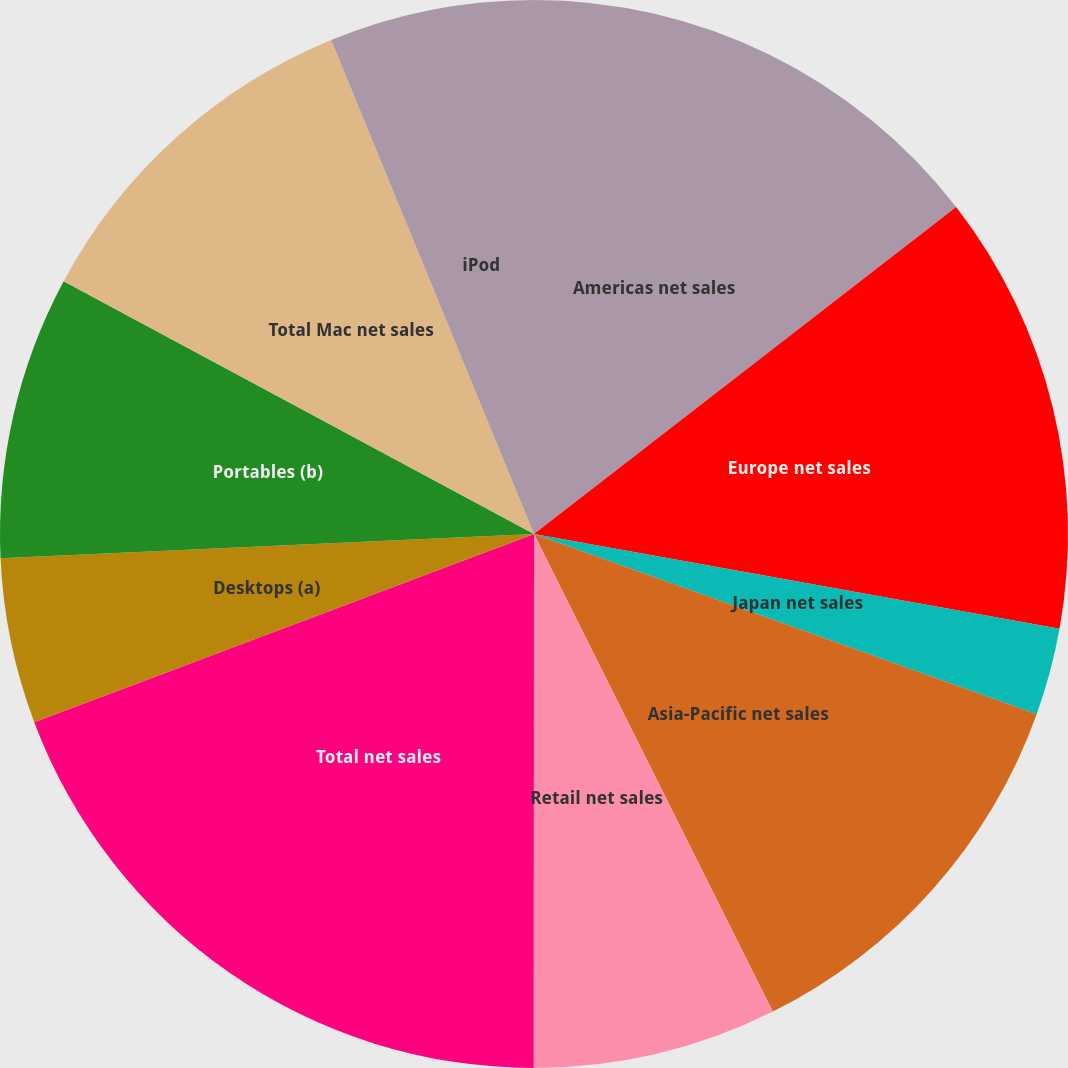Convert chart. <chart><loc_0><loc_0><loc_500><loc_500><pie_chart><fcel>Americas net sales<fcel>Europe net sales<fcel>Japan net sales<fcel>Asia-Pacific net sales<fcel>Retail net sales<fcel>Total net sales<fcel>Desktops (a)<fcel>Portables (b)<fcel>Total Mac net sales<fcel>iPod<nl><fcel>14.51%<fcel>13.33%<fcel>2.64%<fcel>12.14%<fcel>7.39%<fcel>19.26%<fcel>5.01%<fcel>8.57%<fcel>10.95%<fcel>6.2%<nl></chart> 